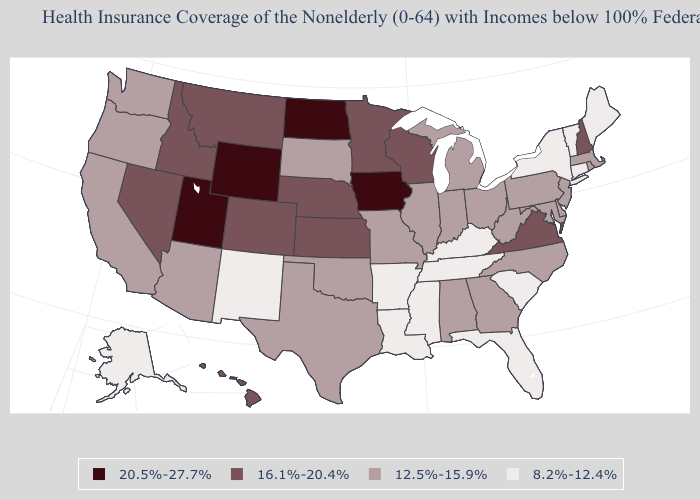Name the states that have a value in the range 8.2%-12.4%?
Write a very short answer. Alaska, Arkansas, Connecticut, Florida, Kentucky, Louisiana, Maine, Mississippi, New Mexico, New York, South Carolina, Tennessee, Vermont. Name the states that have a value in the range 20.5%-27.7%?
Concise answer only. Iowa, North Dakota, Utah, Wyoming. Does Arizona have a lower value than Iowa?
Write a very short answer. Yes. Does Kentucky have a lower value than Maryland?
Concise answer only. Yes. What is the lowest value in the USA?
Give a very brief answer. 8.2%-12.4%. What is the lowest value in the USA?
Quick response, please. 8.2%-12.4%. Among the states that border Washington , which have the highest value?
Answer briefly. Idaho. What is the value of New Hampshire?
Write a very short answer. 16.1%-20.4%. What is the value of Texas?
Be succinct. 12.5%-15.9%. Does the first symbol in the legend represent the smallest category?
Answer briefly. No. Which states have the highest value in the USA?
Concise answer only. Iowa, North Dakota, Utah, Wyoming. Name the states that have a value in the range 12.5%-15.9%?
Quick response, please. Alabama, Arizona, California, Delaware, Georgia, Illinois, Indiana, Maryland, Massachusetts, Michigan, Missouri, New Jersey, North Carolina, Ohio, Oklahoma, Oregon, Pennsylvania, Rhode Island, South Dakota, Texas, Washington, West Virginia. Does Iowa have the highest value in the USA?
Quick response, please. Yes. Does the first symbol in the legend represent the smallest category?
Concise answer only. No. What is the value of Alaska?
Keep it brief. 8.2%-12.4%. 